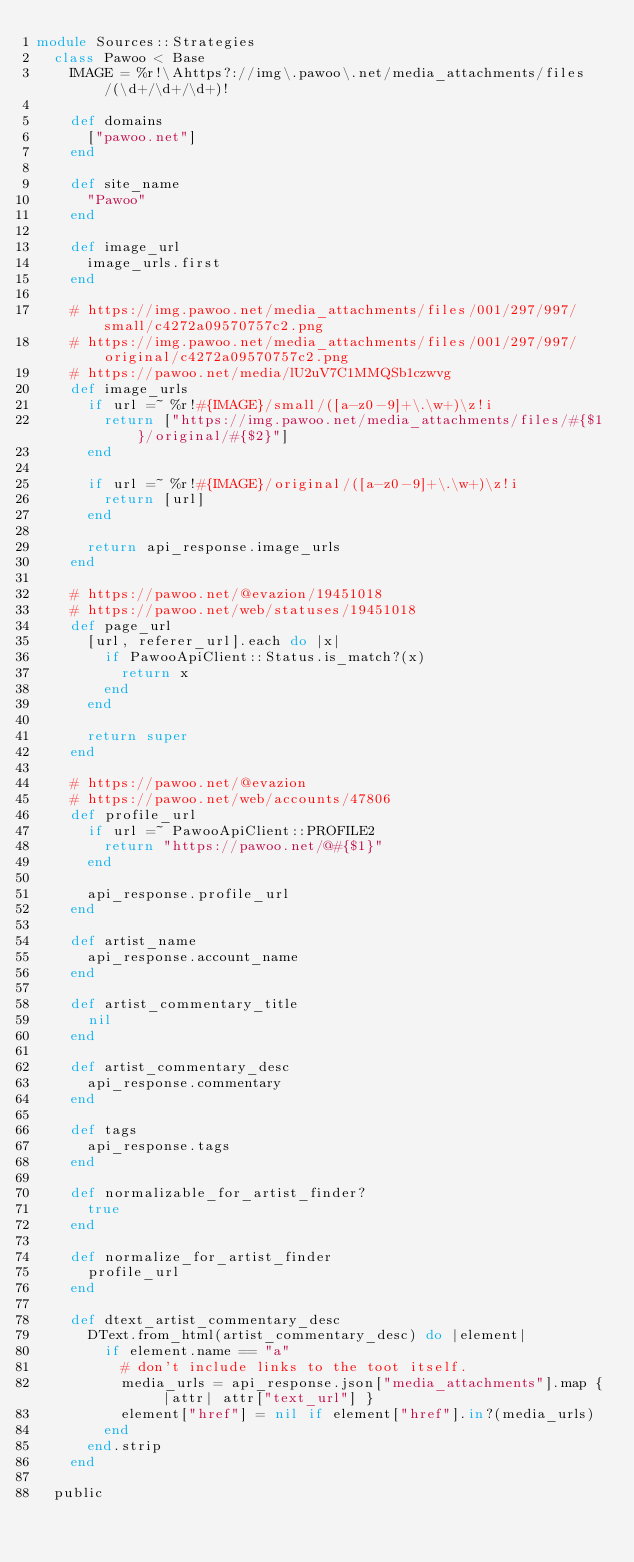<code> <loc_0><loc_0><loc_500><loc_500><_Ruby_>module Sources::Strategies
  class Pawoo < Base
    IMAGE = %r!\Ahttps?://img\.pawoo\.net/media_attachments/files/(\d+/\d+/\d+)!

    def domains
      ["pawoo.net"]
    end

    def site_name
      "Pawoo"
    end

    def image_url
      image_urls.first
    end

    # https://img.pawoo.net/media_attachments/files/001/297/997/small/c4272a09570757c2.png
    # https://img.pawoo.net/media_attachments/files/001/297/997/original/c4272a09570757c2.png
    # https://pawoo.net/media/lU2uV7C1MMQSb1czwvg
    def image_urls
      if url =~ %r!#{IMAGE}/small/([a-z0-9]+\.\w+)\z!i
        return ["https://img.pawoo.net/media_attachments/files/#{$1}/original/#{$2}"]
      end

      if url =~ %r!#{IMAGE}/original/([a-z0-9]+\.\w+)\z!i
        return [url]
      end

      return api_response.image_urls
    end

    # https://pawoo.net/@evazion/19451018
    # https://pawoo.net/web/statuses/19451018
    def page_url
      [url, referer_url].each do |x|
        if PawooApiClient::Status.is_match?(x)
          return x
        end
      end

      return super
    end

    # https://pawoo.net/@evazion
    # https://pawoo.net/web/accounts/47806
    def profile_url
      if url =~ PawooApiClient::PROFILE2
        return "https://pawoo.net/@#{$1}"
      end

      api_response.profile_url
    end

    def artist_name
      api_response.account_name
    end

    def artist_commentary_title
      nil
    end

    def artist_commentary_desc
      api_response.commentary
    end

    def tags
      api_response.tags
    end

    def normalizable_for_artist_finder?
      true
    end

    def normalize_for_artist_finder
      profile_url
    end

    def dtext_artist_commentary_desc
      DText.from_html(artist_commentary_desc) do |element|
        if element.name == "a"
          # don't include links to the toot itself.
          media_urls = api_response.json["media_attachments"].map { |attr| attr["text_url"] }
          element["href"] = nil if element["href"].in?(media_urls)
        end
      end.strip
    end

  public
</code> 